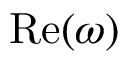Convert formula to latex. <formula><loc_0><loc_0><loc_500><loc_500>R e ( \omega )</formula> 